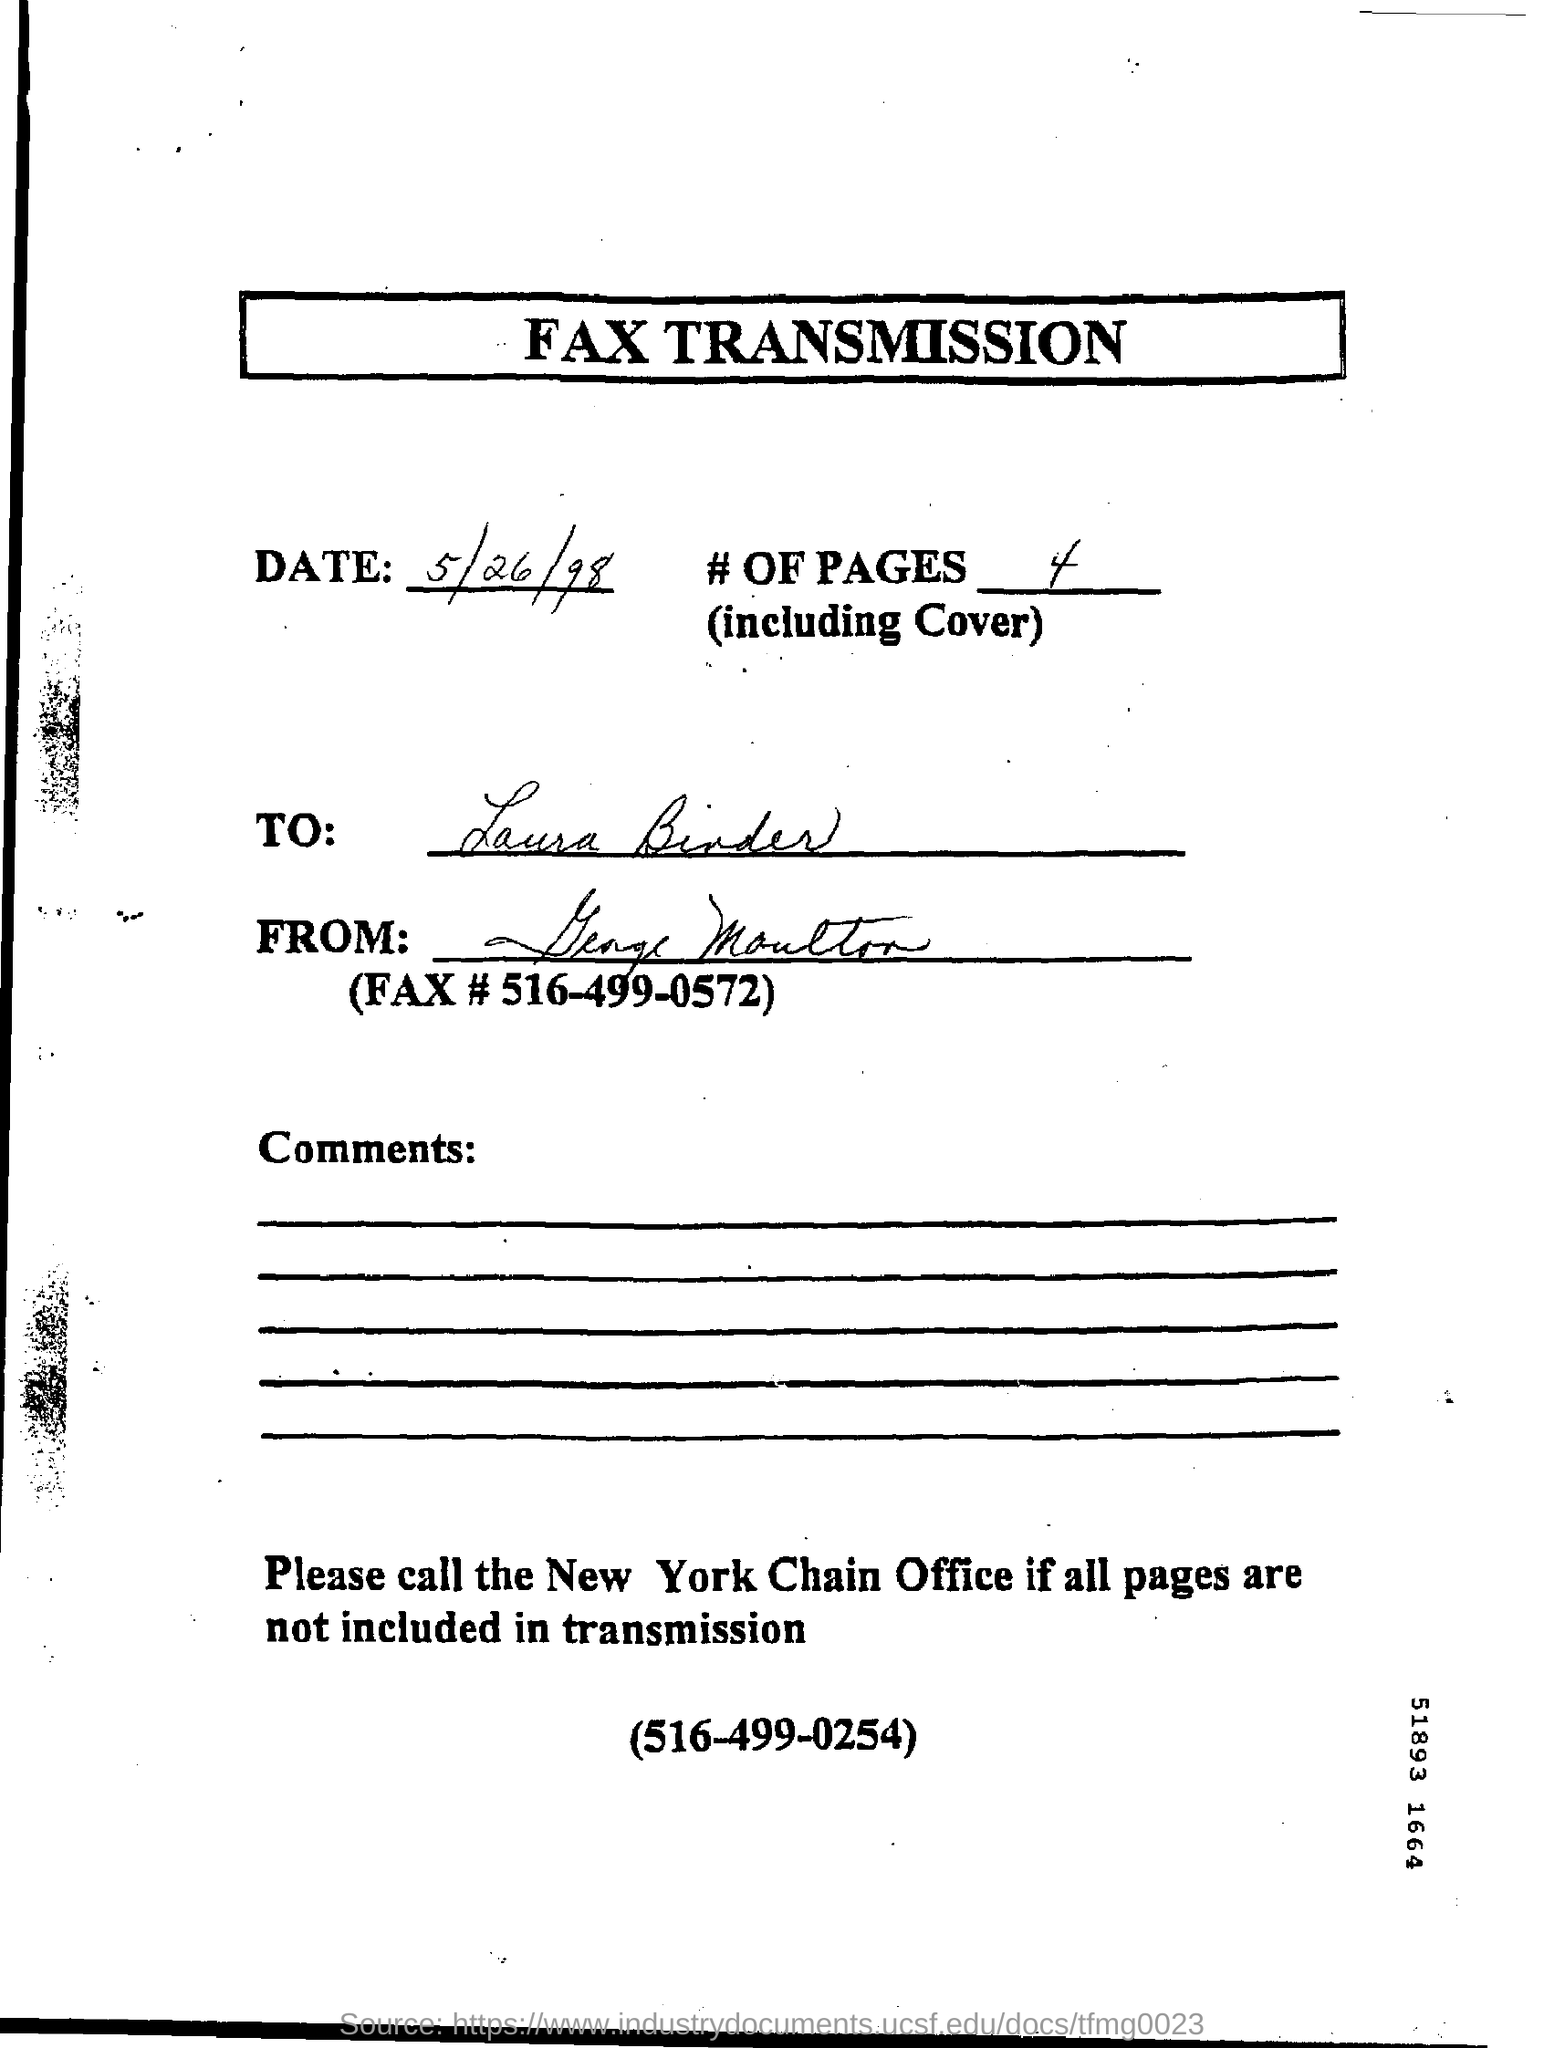What is the heading of the page ?
Your answer should be compact. Fax transmission. When is the fax transmission dated ?
Keep it short and to the point. 5/26/98. How many # of pages ( including cover ) are there ?
Offer a terse response. 4. What is the fax#?
Offer a very short reply. 516-499-0572. 